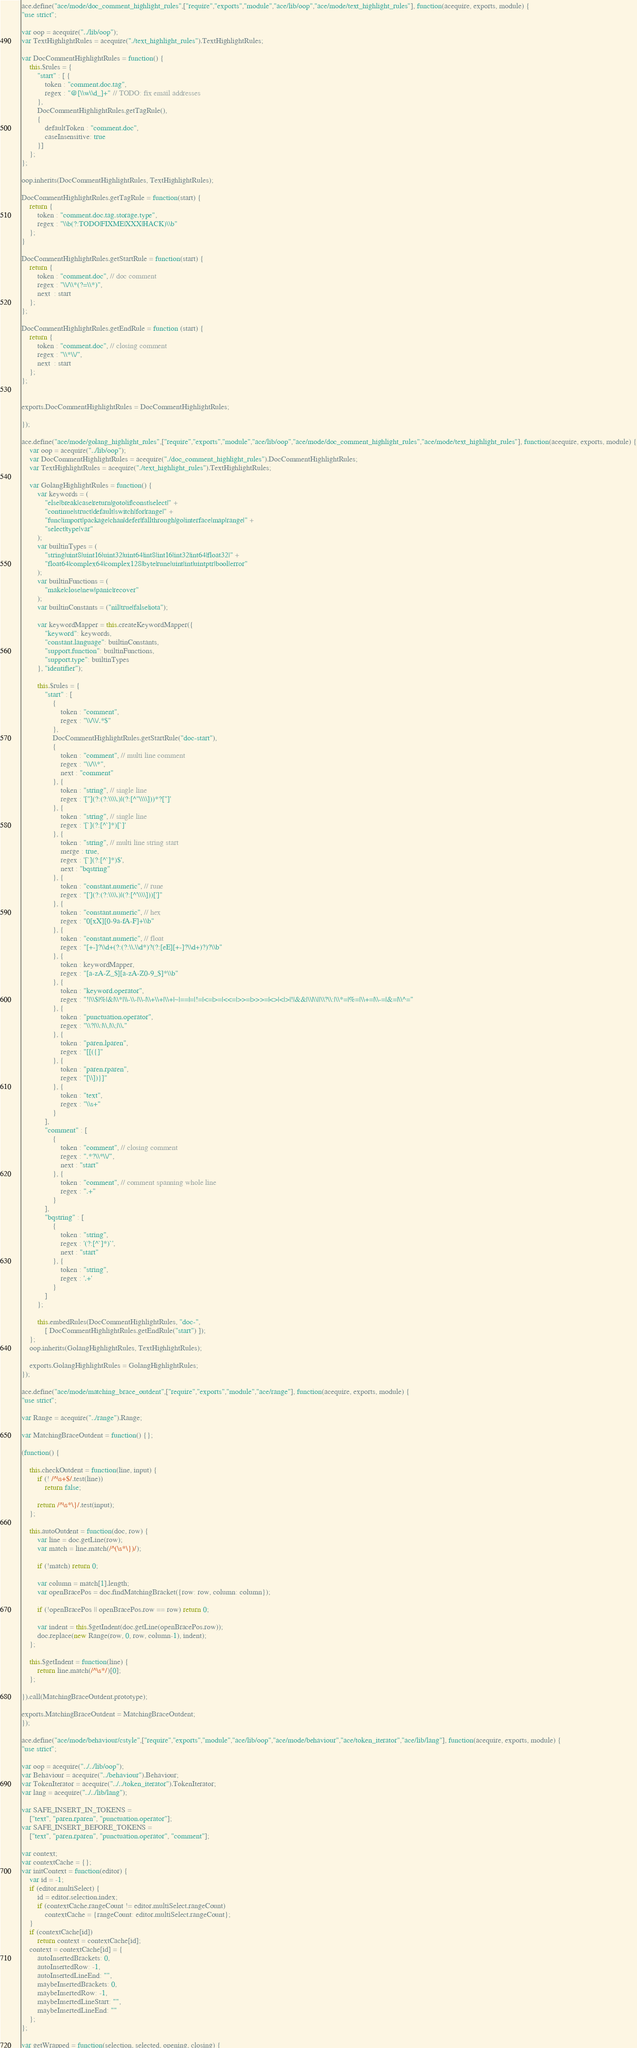<code> <loc_0><loc_0><loc_500><loc_500><_JavaScript_>ace.define("ace/mode/doc_comment_highlight_rules",["require","exports","module","ace/lib/oop","ace/mode/text_highlight_rules"], function(acequire, exports, module) {
"use strict";

var oop = acequire("../lib/oop");
var TextHighlightRules = acequire("./text_highlight_rules").TextHighlightRules;

var DocCommentHighlightRules = function() {
    this.$rules = {
        "start" : [ {
            token : "comment.doc.tag",
            regex : "@[\\w\\d_]+" // TODO: fix email addresses
        },
        DocCommentHighlightRules.getTagRule(),
        {
            defaultToken : "comment.doc",
            caseInsensitive: true
        }]
    };
};

oop.inherits(DocCommentHighlightRules, TextHighlightRules);

DocCommentHighlightRules.getTagRule = function(start) {
    return {
        token : "comment.doc.tag.storage.type",
        regex : "\\b(?:TODO|FIXME|XXX|HACK)\\b"
    };
}

DocCommentHighlightRules.getStartRule = function(start) {
    return {
        token : "comment.doc", // doc comment
        regex : "\\/\\*(?=\\*)",
        next  : start
    };
};

DocCommentHighlightRules.getEndRule = function (start) {
    return {
        token : "comment.doc", // closing comment
        regex : "\\*\\/",
        next  : start
    };
};


exports.DocCommentHighlightRules = DocCommentHighlightRules;

});

ace.define("ace/mode/golang_highlight_rules",["require","exports","module","ace/lib/oop","ace/mode/doc_comment_highlight_rules","ace/mode/text_highlight_rules"], function(acequire, exports, module) {
    var oop = acequire("../lib/oop");
    var DocCommentHighlightRules = acequire("./doc_comment_highlight_rules").DocCommentHighlightRules;
    var TextHighlightRules = acequire("./text_highlight_rules").TextHighlightRules;

    var GolangHighlightRules = function() {
        var keywords = (
            "else|break|case|return|goto|if|const|select|" +
            "continue|struct|default|switch|for|range|" +
            "func|import|package|chan|defer|fallthrough|go|interface|map|range|" +
            "select|type|var"
        );
        var builtinTypes = (
            "string|uint8|uint16|uint32|uint64|int8|int16|int32|int64|float32|" +
            "float64|complex64|complex128|byte|rune|uint|int|uintptr|bool|error"
        );
        var builtinFunctions = (
            "make|close|new|panic|recover"
        );
        var builtinConstants = ("nil|true|false|iota");

        var keywordMapper = this.createKeywordMapper({
            "keyword": keywords,
            "constant.language": builtinConstants,
            "support.function": builtinFunctions,
            "support.type": builtinTypes
        }, "identifier");

        this.$rules = {
            "start" : [
                {
                    token : "comment",
                    regex : "\\/\\/.*$"
                },
                DocCommentHighlightRules.getStartRule("doc-start"),
                {
                    token : "comment", // multi line comment
                    regex : "\\/\\*",
                    next : "comment"
                }, {
                    token : "string", // single line
                    regex : '["](?:(?:\\\\.)|(?:[^"\\\\]))*?["]'
                }, {
                    token : "string", // single line
                    regex : '[`](?:[^`]*)[`]'
                }, {
                    token : "string", // multi line string start
                    merge : true,
                    regex : '[`](?:[^`]*)$',
                    next : "bqstring"
                }, {
                    token : "constant.numeric", // rune
                    regex : "['](?:(?:\\\\.)|(?:[^'\\\\]))[']"
                }, {
                    token : "constant.numeric", // hex
                    regex : "0[xX][0-9a-fA-F]+\\b"
                }, {
                    token : "constant.numeric", // float
                    regex : "[+-]?\\d+(?:(?:\\.\\d*)?(?:[eE][+-]?\\d+)?)?\\b"
                }, {
                    token : keywordMapper,
                    regex : "[a-zA-Z_$][a-zA-Z0-9_$]*\\b"
                }, {
                    token : "keyword.operator",
                    regex : "!|\\$|%|&|\\*|\\-\\-|\\-|\\+\\+|\\+|~|==|=|!=|<=|>=|<<=|>>=|>>>=|<>|<|>|!|&&|\\|\\||\\?\\:|\\*=|%=|\\+=|\\-=|&=|\\^="
                }, {
                    token : "punctuation.operator",
                    regex : "\\?|\\:|\\,|\\;|\\."
                }, {
                    token : "paren.lparen",
                    regex : "[[({]"
                }, {
                    token : "paren.rparen",
                    regex : "[\\])}]"
                }, {
                    token : "text",
                    regex : "\\s+"
                }
            ],
            "comment" : [
                {
                    token : "comment", // closing comment
                    regex : ".*?\\*\\/",
                    next : "start"
                }, {
                    token : "comment", // comment spanning whole line
                    regex : ".+"
                }
            ],
            "bqstring" : [
                {
                    token : "string",
                    regex : '(?:[^`]*)`',
                    next : "start"
                }, {
                    token : "string",
                    regex : '.+'
                }
            ]
        };

        this.embedRules(DocCommentHighlightRules, "doc-",
            [ DocCommentHighlightRules.getEndRule("start") ]);
    };
    oop.inherits(GolangHighlightRules, TextHighlightRules);

    exports.GolangHighlightRules = GolangHighlightRules;
});

ace.define("ace/mode/matching_brace_outdent",["require","exports","module","ace/range"], function(acequire, exports, module) {
"use strict";

var Range = acequire("../range").Range;

var MatchingBraceOutdent = function() {};

(function() {

    this.checkOutdent = function(line, input) {
        if (! /^\s+$/.test(line))
            return false;

        return /^\s*\}/.test(input);
    };

    this.autoOutdent = function(doc, row) {
        var line = doc.getLine(row);
        var match = line.match(/^(\s*\})/);

        if (!match) return 0;

        var column = match[1].length;
        var openBracePos = doc.findMatchingBracket({row: row, column: column});

        if (!openBracePos || openBracePos.row == row) return 0;

        var indent = this.$getIndent(doc.getLine(openBracePos.row));
        doc.replace(new Range(row, 0, row, column-1), indent);
    };

    this.$getIndent = function(line) {
        return line.match(/^\s*/)[0];
    };

}).call(MatchingBraceOutdent.prototype);

exports.MatchingBraceOutdent = MatchingBraceOutdent;
});

ace.define("ace/mode/behaviour/cstyle",["require","exports","module","ace/lib/oop","ace/mode/behaviour","ace/token_iterator","ace/lib/lang"], function(acequire, exports, module) {
"use strict";

var oop = acequire("../../lib/oop");
var Behaviour = acequire("../behaviour").Behaviour;
var TokenIterator = acequire("../../token_iterator").TokenIterator;
var lang = acequire("../../lib/lang");

var SAFE_INSERT_IN_TOKENS =
    ["text", "paren.rparen", "punctuation.operator"];
var SAFE_INSERT_BEFORE_TOKENS =
    ["text", "paren.rparen", "punctuation.operator", "comment"];

var context;
var contextCache = {};
var initContext = function(editor) {
    var id = -1;
    if (editor.multiSelect) {
        id = editor.selection.index;
        if (contextCache.rangeCount != editor.multiSelect.rangeCount)
            contextCache = {rangeCount: editor.multiSelect.rangeCount};
    }
    if (contextCache[id])
        return context = contextCache[id];
    context = contextCache[id] = {
        autoInsertedBrackets: 0,
        autoInsertedRow: -1,
        autoInsertedLineEnd: "",
        maybeInsertedBrackets: 0,
        maybeInsertedRow: -1,
        maybeInsertedLineStart: "",
        maybeInsertedLineEnd: ""
    };
};

var getWrapped = function(selection, selected, opening, closing) {</code> 